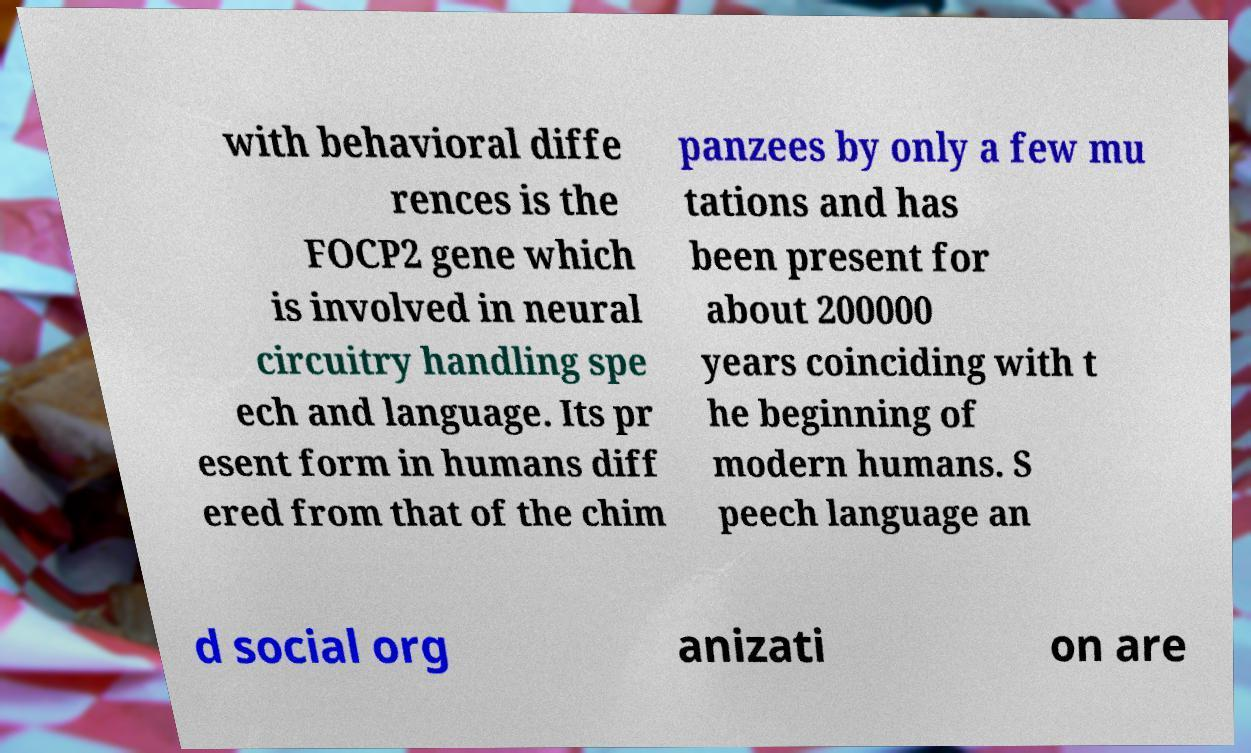Could you assist in decoding the text presented in this image and type it out clearly? with behavioral diffe rences is the FOCP2 gene which is involved in neural circuitry handling spe ech and language. Its pr esent form in humans diff ered from that of the chim panzees by only a few mu tations and has been present for about 200000 years coinciding with t he beginning of modern humans. S peech language an d social org anizati on are 